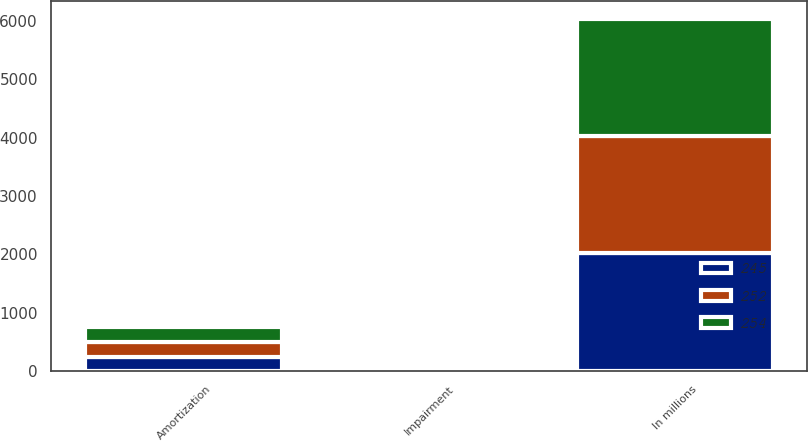<chart> <loc_0><loc_0><loc_500><loc_500><stacked_bar_chart><ecel><fcel>In millions<fcel>Amortization<fcel>Impairment<nl><fcel>245<fcel>2014<fcel>242<fcel>3<nl><fcel>252<fcel>2013<fcel>250<fcel>2<nl><fcel>254<fcel>2012<fcel>252<fcel>1<nl></chart> 